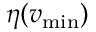Convert formula to latex. <formula><loc_0><loc_0><loc_500><loc_500>\eta ( v _ { \min } )</formula> 